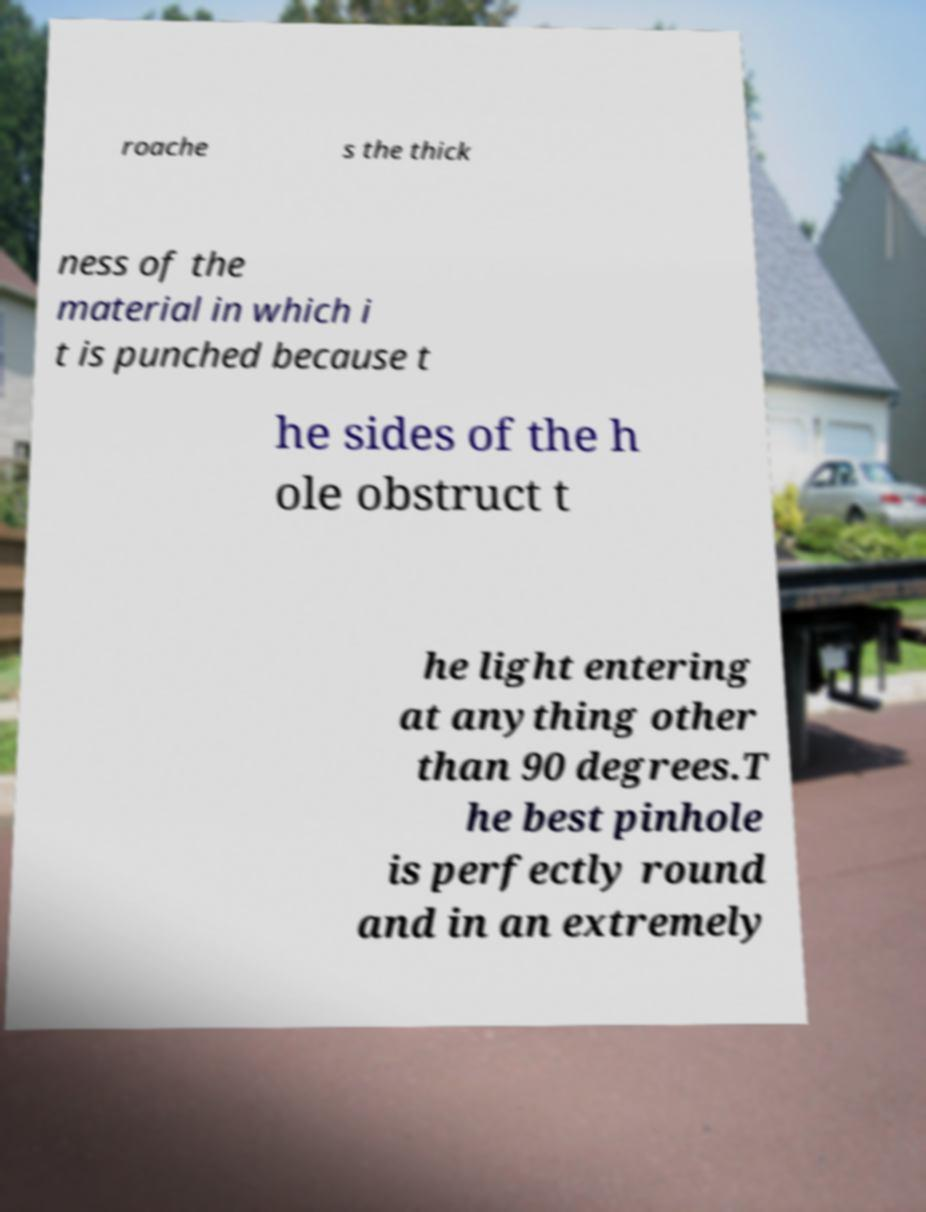Please identify and transcribe the text found in this image. roache s the thick ness of the material in which i t is punched because t he sides of the h ole obstruct t he light entering at anything other than 90 degrees.T he best pinhole is perfectly round and in an extremely 